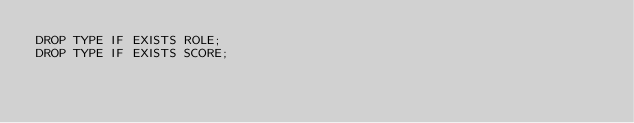Convert code to text. <code><loc_0><loc_0><loc_500><loc_500><_SQL_>DROP TYPE IF EXISTS ROLE;
DROP TYPE IF EXISTS SCORE;</code> 